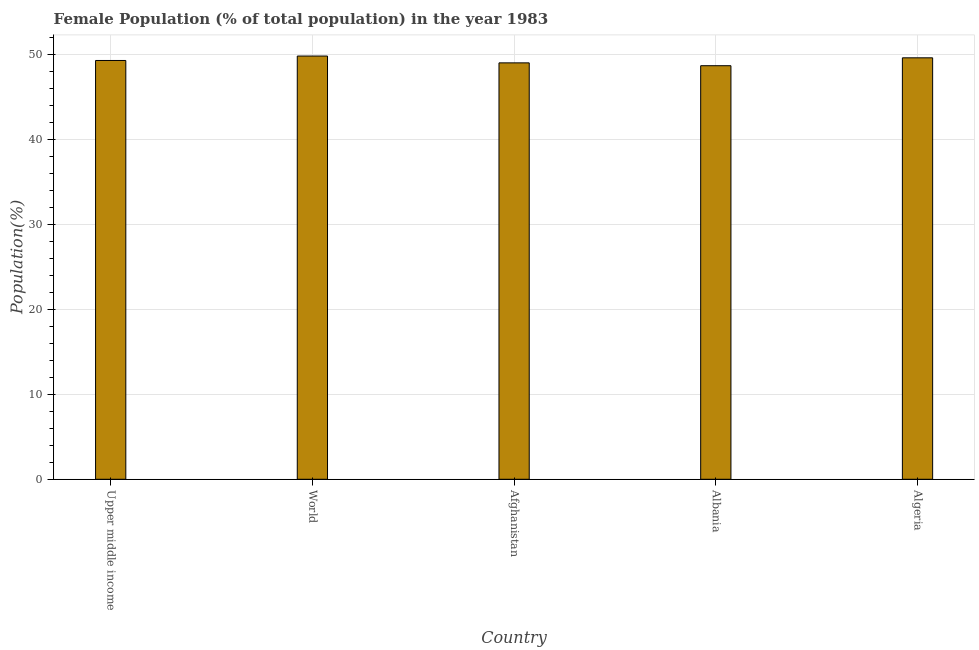Does the graph contain grids?
Your response must be concise. Yes. What is the title of the graph?
Your response must be concise. Female Population (% of total population) in the year 1983. What is the label or title of the X-axis?
Provide a succinct answer. Country. What is the label or title of the Y-axis?
Offer a terse response. Population(%). What is the female population in Upper middle income?
Make the answer very short. 49.26. Across all countries, what is the maximum female population?
Keep it short and to the point. 49.78. Across all countries, what is the minimum female population?
Your answer should be compact. 48.64. In which country was the female population minimum?
Offer a very short reply. Albania. What is the sum of the female population?
Ensure brevity in your answer.  246.24. What is the difference between the female population in Afghanistan and Algeria?
Offer a terse response. -0.59. What is the average female population per country?
Provide a succinct answer. 49.25. What is the median female population?
Keep it short and to the point. 49.26. Is the female population in Algeria less than that in Upper middle income?
Keep it short and to the point. No. What is the difference between the highest and the second highest female population?
Keep it short and to the point. 0.21. What is the difference between the highest and the lowest female population?
Ensure brevity in your answer.  1.14. In how many countries, is the female population greater than the average female population taken over all countries?
Your answer should be very brief. 3. How many bars are there?
Provide a succinct answer. 5. How many countries are there in the graph?
Offer a terse response. 5. Are the values on the major ticks of Y-axis written in scientific E-notation?
Make the answer very short. No. What is the Population(%) in Upper middle income?
Offer a very short reply. 49.26. What is the Population(%) of World?
Offer a terse response. 49.78. What is the Population(%) in Afghanistan?
Provide a succinct answer. 48.98. What is the Population(%) of Albania?
Offer a very short reply. 48.64. What is the Population(%) in Algeria?
Ensure brevity in your answer.  49.57. What is the difference between the Population(%) in Upper middle income and World?
Provide a succinct answer. -0.52. What is the difference between the Population(%) in Upper middle income and Afghanistan?
Offer a very short reply. 0.28. What is the difference between the Population(%) in Upper middle income and Albania?
Offer a very short reply. 0.61. What is the difference between the Population(%) in Upper middle income and Algeria?
Keep it short and to the point. -0.31. What is the difference between the Population(%) in World and Afghanistan?
Provide a succinct answer. 0.8. What is the difference between the Population(%) in World and Albania?
Your response must be concise. 1.14. What is the difference between the Population(%) in World and Algeria?
Ensure brevity in your answer.  0.21. What is the difference between the Population(%) in Afghanistan and Albania?
Keep it short and to the point. 0.34. What is the difference between the Population(%) in Afghanistan and Algeria?
Your response must be concise. -0.59. What is the difference between the Population(%) in Albania and Algeria?
Offer a terse response. -0.93. What is the ratio of the Population(%) in Upper middle income to that in World?
Your response must be concise. 0.99. What is the ratio of the Population(%) in Upper middle income to that in Albania?
Make the answer very short. 1.01. What is the ratio of the Population(%) in Upper middle income to that in Algeria?
Offer a very short reply. 0.99. What is the ratio of the Population(%) in World to that in Afghanistan?
Provide a succinct answer. 1.02. What is the ratio of the Population(%) in World to that in Albania?
Ensure brevity in your answer.  1.02. 